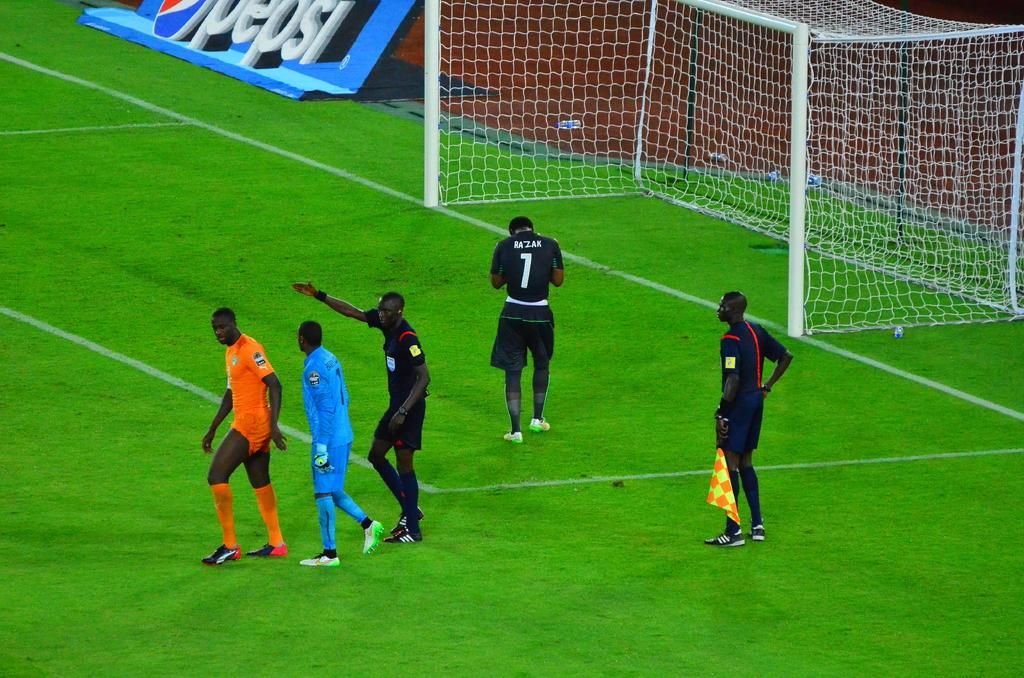Provide a one-sentence caption for the provided image. a player on a field with the number 7 on it. 